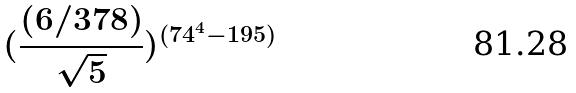Convert formula to latex. <formula><loc_0><loc_0><loc_500><loc_500>( \frac { ( 6 / 3 7 8 ) } { \sqrt { 5 } } ) ^ { ( 7 4 ^ { 4 } - 1 9 5 ) }</formula> 